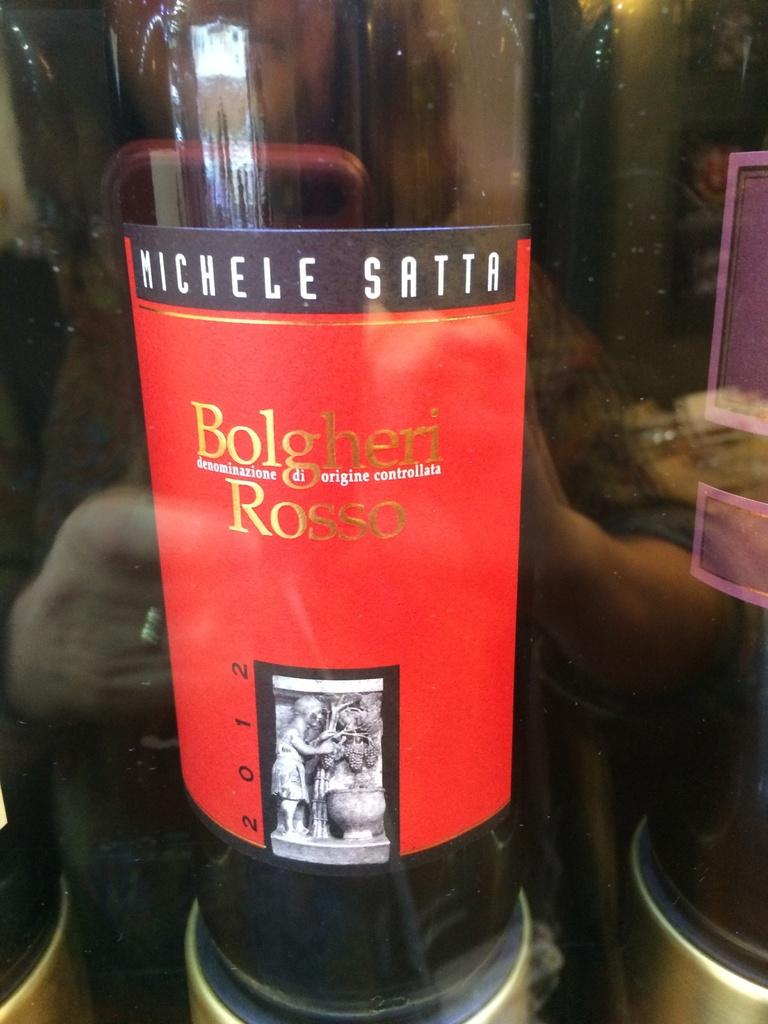Provide a one-sentence caption for the provided image. bottle of wine called bolgheri rosse from 2012. 